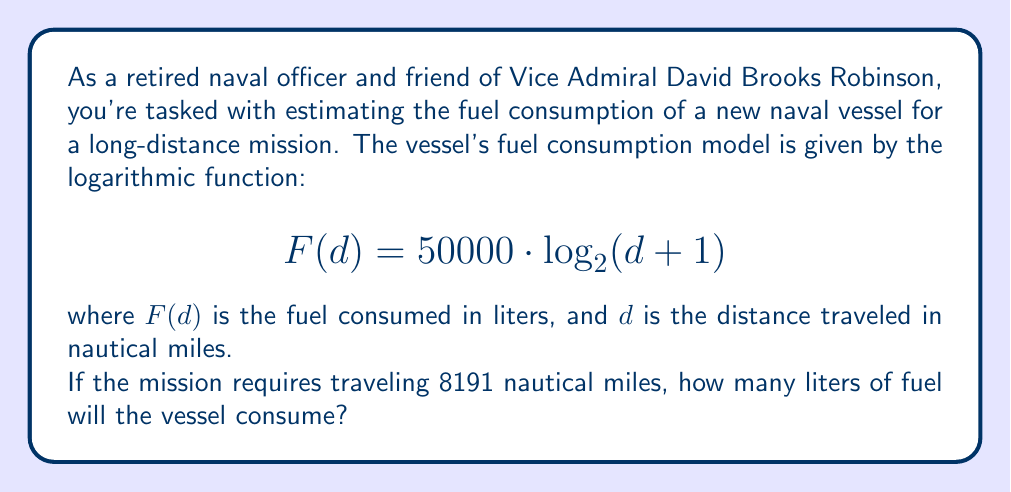Could you help me with this problem? To solve this problem, we need to use the given logarithmic function and substitute the distance value. Let's break it down step-by-step:

1) The fuel consumption function is:
   $$ F(d) = 50000 \cdot \log_{2}(d + 1) $$

2) We need to find $F(8191)$, so let's substitute $d = 8191$:
   $$ F(8191) = 50000 \cdot \log_{2}(8191 + 1) $$

3) Simplify inside the parentheses:
   $$ F(8191) = 50000 \cdot \log_{2}(8192) $$

4) Now, we need to calculate $\log_{2}(8192)$. As naval officers, we might recognize that 8192 is $2^{13}$, which simplifies our calculation:
   $$ \log_{2}(8192) = \log_{2}(2^{13}) = 13 $$

5) Substituting this back into our equation:
   $$ F(8191) = 50000 \cdot 13 $$

6) Finally, we can calculate the result:
   $$ F(8191) = 650000 $$

Therefore, the vessel will consume 650,000 liters of fuel for the 8191 nautical mile journey.
Answer: 650,000 liters 